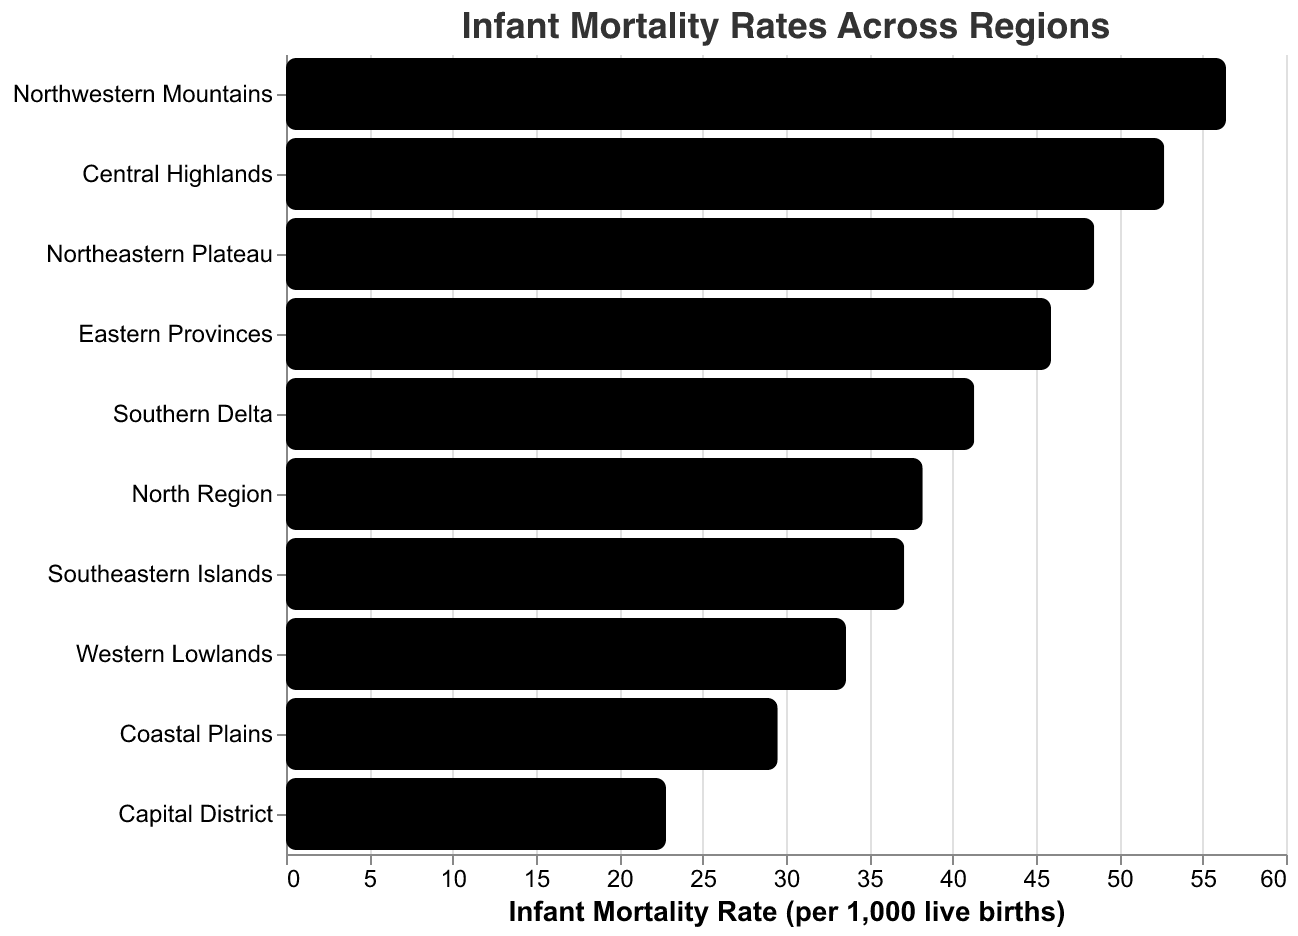What is the title of the figure? The title is usually located at the top of the chart and indicates the primary focus of the figure.
Answer: "Infant Mortality Rates Across Regions" Which region has the highest infant mortality rate? Look for the bar that extends the farthest to the right on the x-axis, as this represents the highest infant mortality rate.
Answer: Northwestern Mountains What is the infant mortality rate for the Capital District? Find the bar corresponding to the Capital District on the y-axis and read its value on the x-axis.
Answer: 22.8 How many regions have an infant mortality rate higher than 40? Count the bars on the chart that extend past the 40 mark on the x-axis.
Answer: 6 Which regions have lower infant mortality rates compared to the Southern Delta? Identify the infant mortality rate for the Southern Delta, then list the regions with bars that extend less far on the x-axis.
Answer: Coastal Plains, Western Lowlands, Capital District What is the difference in infant mortality rate between the Central Highlands and the North Region? Subtract the infant mortality rate of the North Region from that of the Central Highlands.
Answer: 52.7 - 38.2 = 14.5 What is the average infant mortality rate across all regions? Sum the infant mortality rates of all regions and divide by the number of regions (10).
Answer: (38.2 + 52.7 + 29.5 + 45.9 + 33.6 + 41.3 + 22.8 + 56.4 + 37.1 + 48.5) / 10 = 40.6 Which region has the median infant mortality rate and what is its value? Arrange the infant mortality rates in ascending order and find the middle value, as there are 10 regions, the median will be the average of the 5th and 6th values.
Answer: Western Lowlands and Southern Delta, average value = (33.6 + 41.3) / 2 = 37.45 